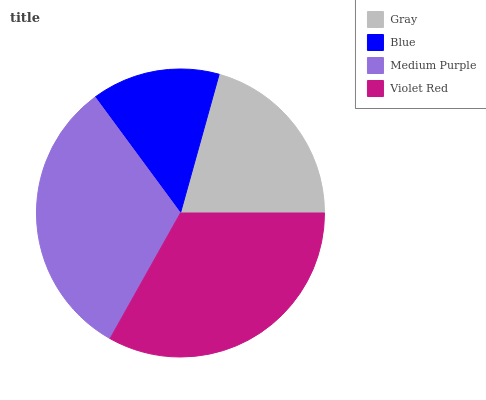Is Blue the minimum?
Answer yes or no. Yes. Is Violet Red the maximum?
Answer yes or no. Yes. Is Medium Purple the minimum?
Answer yes or no. No. Is Medium Purple the maximum?
Answer yes or no. No. Is Medium Purple greater than Blue?
Answer yes or no. Yes. Is Blue less than Medium Purple?
Answer yes or no. Yes. Is Blue greater than Medium Purple?
Answer yes or no. No. Is Medium Purple less than Blue?
Answer yes or no. No. Is Medium Purple the high median?
Answer yes or no. Yes. Is Gray the low median?
Answer yes or no. Yes. Is Blue the high median?
Answer yes or no. No. Is Medium Purple the low median?
Answer yes or no. No. 